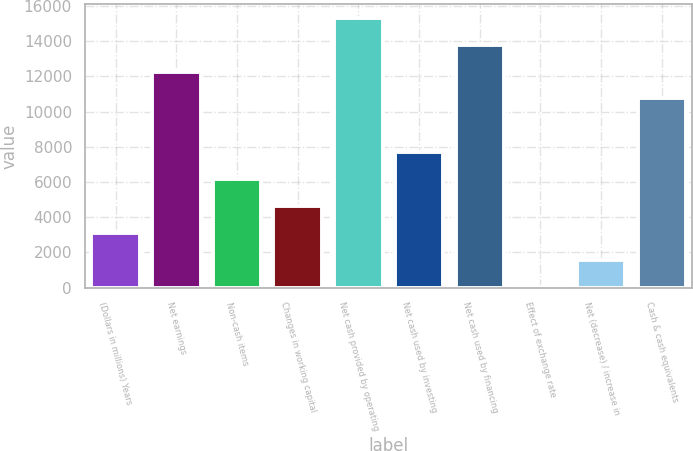Convert chart to OTSL. <chart><loc_0><loc_0><loc_500><loc_500><bar_chart><fcel>(Dollars in millions) Years<fcel>Net earnings<fcel>Non-cash items<fcel>Changes in working capital<fcel>Net cash provided by operating<fcel>Net cash used by investing<fcel>Net cash used by financing<fcel>Effect of exchange rate<fcel>Net (decrease) / increase in<fcel>Cash & cash equivalents<nl><fcel>3106.8<fcel>12268.2<fcel>6160.6<fcel>4633.7<fcel>15322<fcel>7687.5<fcel>13795.1<fcel>53<fcel>1579.9<fcel>10741.3<nl></chart> 